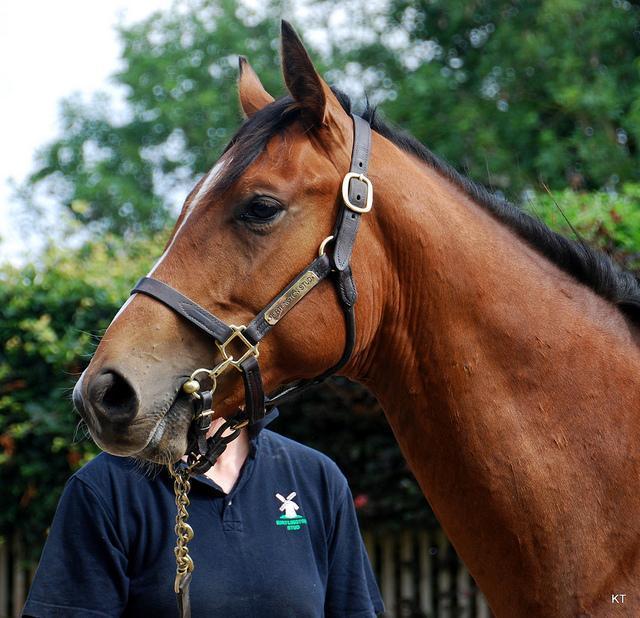Is this affirmation: "The horse is by the person." correct?
Answer yes or no. Yes. 